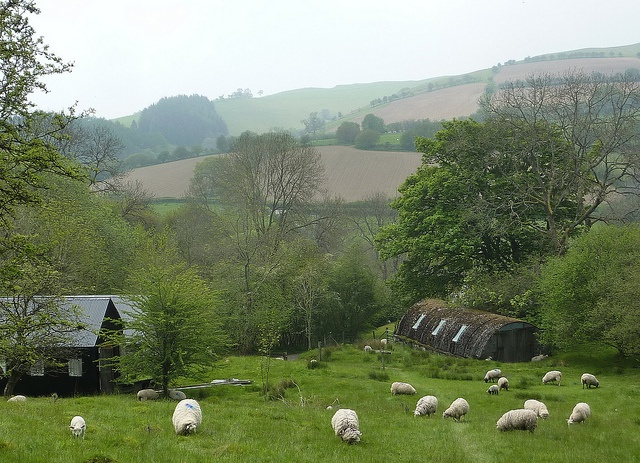Describe the objects in this image and their specific colors. I can see sheep in white, darkgreen, black, and gray tones, sheep in white, beige, darkgray, darkgreen, and gray tones, sheep in white, beige, darkgray, and gray tones, sheep in white, black, gray, darkgray, and darkgreen tones, and sheep in white, darkgreen, gray, olive, and beige tones in this image. 